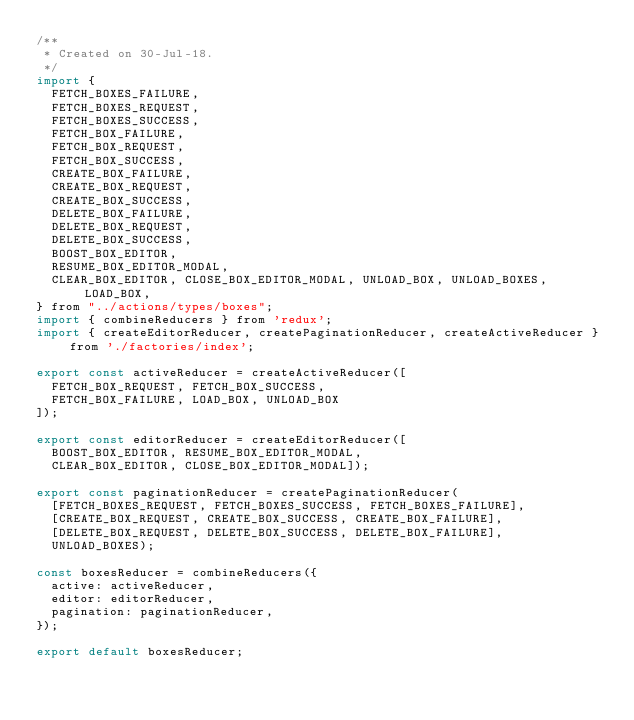Convert code to text. <code><loc_0><loc_0><loc_500><loc_500><_JavaScript_>/**
 * Created on 30-Jul-18.
 */
import {
  FETCH_BOXES_FAILURE,
  FETCH_BOXES_REQUEST,
  FETCH_BOXES_SUCCESS,
  FETCH_BOX_FAILURE,
  FETCH_BOX_REQUEST,
  FETCH_BOX_SUCCESS,
  CREATE_BOX_FAILURE,
  CREATE_BOX_REQUEST,
  CREATE_BOX_SUCCESS,
  DELETE_BOX_FAILURE,
  DELETE_BOX_REQUEST,
  DELETE_BOX_SUCCESS,
  BOOST_BOX_EDITOR,
  RESUME_BOX_EDITOR_MODAL,
  CLEAR_BOX_EDITOR, CLOSE_BOX_EDITOR_MODAL, UNLOAD_BOX, UNLOAD_BOXES, LOAD_BOX,
} from "../actions/types/boxes";
import { combineReducers } from 'redux';
import { createEditorReducer, createPaginationReducer, createActiveReducer } from './factories/index';

export const activeReducer = createActiveReducer([
  FETCH_BOX_REQUEST, FETCH_BOX_SUCCESS,
  FETCH_BOX_FAILURE, LOAD_BOX, UNLOAD_BOX
]);

export const editorReducer = createEditorReducer([
  BOOST_BOX_EDITOR, RESUME_BOX_EDITOR_MODAL,
  CLEAR_BOX_EDITOR, CLOSE_BOX_EDITOR_MODAL]);

export const paginationReducer = createPaginationReducer(
  [FETCH_BOXES_REQUEST, FETCH_BOXES_SUCCESS, FETCH_BOXES_FAILURE],
  [CREATE_BOX_REQUEST, CREATE_BOX_SUCCESS, CREATE_BOX_FAILURE],
  [DELETE_BOX_REQUEST, DELETE_BOX_SUCCESS, DELETE_BOX_FAILURE],
  UNLOAD_BOXES);

const boxesReducer = combineReducers({
  active: activeReducer,
  editor: editorReducer,
  pagination: paginationReducer,
});

export default boxesReducer;
</code> 